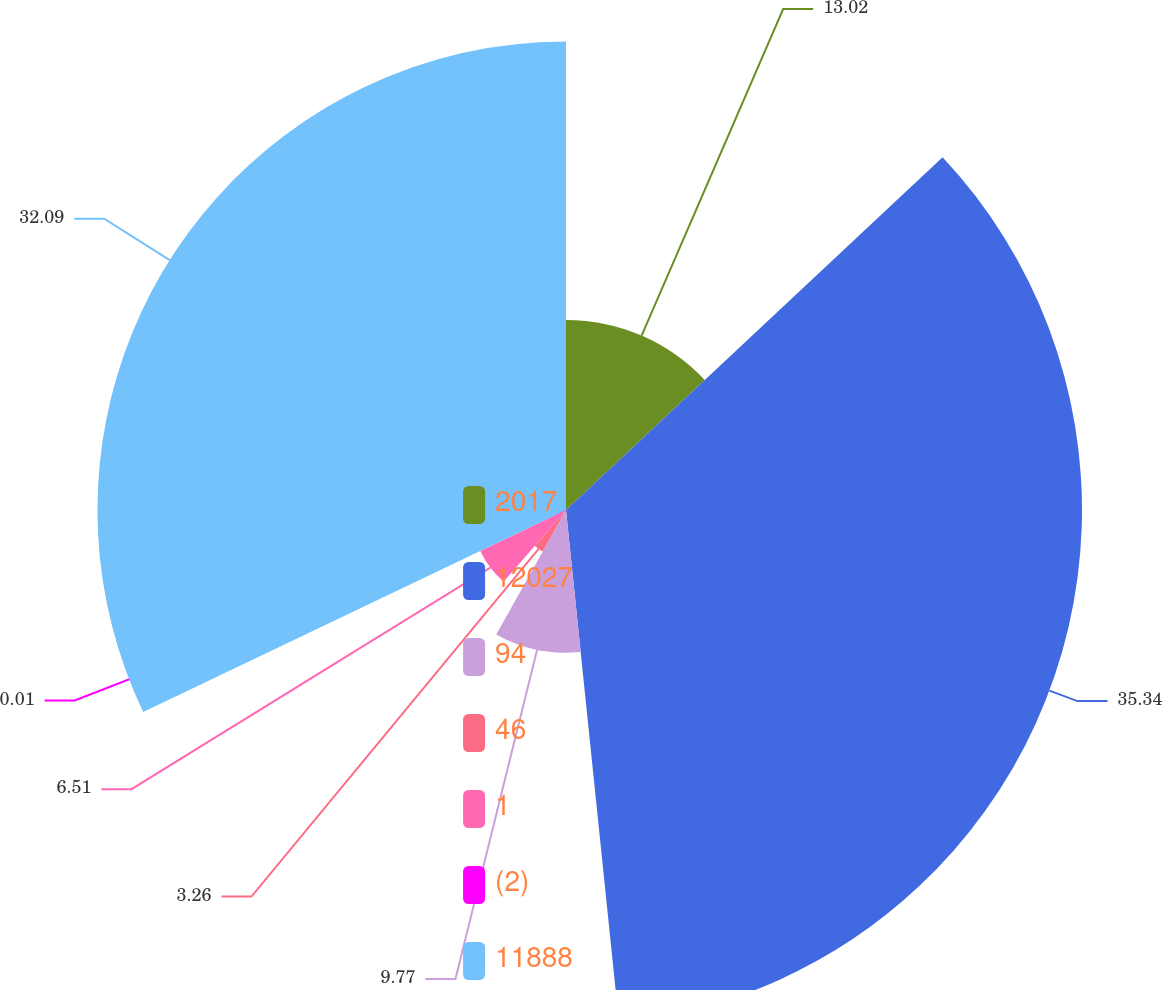<chart> <loc_0><loc_0><loc_500><loc_500><pie_chart><fcel>2017<fcel>12027<fcel>94<fcel>46<fcel>1<fcel>(2)<fcel>11888<nl><fcel>13.02%<fcel>35.34%<fcel>9.77%<fcel>3.26%<fcel>6.51%<fcel>0.01%<fcel>32.09%<nl></chart> 